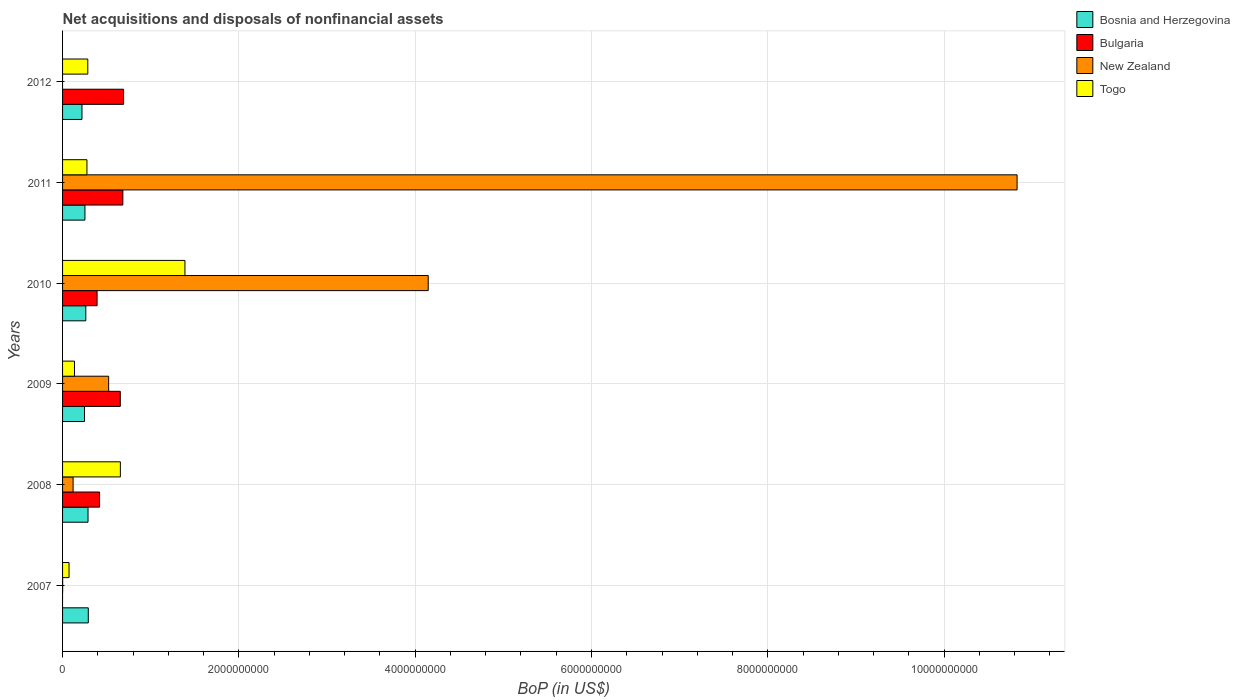Are the number of bars per tick equal to the number of legend labels?
Provide a short and direct response. No. Are the number of bars on each tick of the Y-axis equal?
Make the answer very short. No. How many bars are there on the 5th tick from the top?
Your answer should be compact. 4. What is the label of the 5th group of bars from the top?
Your answer should be compact. 2008. In how many cases, is the number of bars for a given year not equal to the number of legend labels?
Keep it short and to the point. 2. What is the Balance of Payments in Togo in 2011?
Ensure brevity in your answer.  2.76e+08. Across all years, what is the maximum Balance of Payments in Bulgaria?
Provide a succinct answer. 6.92e+08. Across all years, what is the minimum Balance of Payments in Togo?
Keep it short and to the point. 7.34e+07. In which year was the Balance of Payments in Bosnia and Herzegovina maximum?
Make the answer very short. 2007. What is the total Balance of Payments in Bulgaria in the graph?
Offer a very short reply. 2.84e+09. What is the difference between the Balance of Payments in New Zealand in 2008 and that in 2011?
Your response must be concise. -1.07e+1. What is the difference between the Balance of Payments in Bosnia and Herzegovina in 2008 and the Balance of Payments in Togo in 2012?
Give a very brief answer. 2.53e+06. What is the average Balance of Payments in Togo per year?
Provide a short and direct response. 4.69e+08. In the year 2009, what is the difference between the Balance of Payments in Togo and Balance of Payments in Bulgaria?
Offer a very short reply. -5.20e+08. What is the ratio of the Balance of Payments in New Zealand in 2009 to that in 2011?
Your answer should be compact. 0.05. Is the difference between the Balance of Payments in Togo in 2009 and 2010 greater than the difference between the Balance of Payments in Bulgaria in 2009 and 2010?
Offer a terse response. No. What is the difference between the highest and the second highest Balance of Payments in Bulgaria?
Your answer should be compact. 8.50e+06. What is the difference between the highest and the lowest Balance of Payments in Bosnia and Herzegovina?
Give a very brief answer. 7.16e+07. In how many years, is the Balance of Payments in New Zealand greater than the average Balance of Payments in New Zealand taken over all years?
Your answer should be very brief. 2. Is it the case that in every year, the sum of the Balance of Payments in Bosnia and Herzegovina and Balance of Payments in Togo is greater than the sum of Balance of Payments in New Zealand and Balance of Payments in Bulgaria?
Keep it short and to the point. No. How many years are there in the graph?
Your answer should be very brief. 6. Are the values on the major ticks of X-axis written in scientific E-notation?
Provide a succinct answer. No. Does the graph contain any zero values?
Ensure brevity in your answer.  Yes. Does the graph contain grids?
Offer a very short reply. Yes. How many legend labels are there?
Provide a succinct answer. 4. What is the title of the graph?
Provide a succinct answer. Net acquisitions and disposals of nonfinancial assets. What is the label or title of the X-axis?
Ensure brevity in your answer.  BoP (in US$). What is the BoP (in US$) in Bosnia and Herzegovina in 2007?
Your response must be concise. 2.92e+08. What is the BoP (in US$) of Bulgaria in 2007?
Give a very brief answer. 0. What is the BoP (in US$) in New Zealand in 2007?
Offer a terse response. 7.64e+05. What is the BoP (in US$) in Togo in 2007?
Your answer should be very brief. 7.34e+07. What is the BoP (in US$) of Bosnia and Herzegovina in 2008?
Give a very brief answer. 2.89e+08. What is the BoP (in US$) of Bulgaria in 2008?
Provide a short and direct response. 4.20e+08. What is the BoP (in US$) of New Zealand in 2008?
Make the answer very short. 1.19e+08. What is the BoP (in US$) of Togo in 2008?
Provide a short and direct response. 6.56e+08. What is the BoP (in US$) of Bosnia and Herzegovina in 2009?
Ensure brevity in your answer.  2.49e+08. What is the BoP (in US$) in Bulgaria in 2009?
Offer a very short reply. 6.55e+08. What is the BoP (in US$) of New Zealand in 2009?
Offer a very short reply. 5.23e+08. What is the BoP (in US$) in Togo in 2009?
Ensure brevity in your answer.  1.35e+08. What is the BoP (in US$) of Bosnia and Herzegovina in 2010?
Your answer should be compact. 2.64e+08. What is the BoP (in US$) of Bulgaria in 2010?
Offer a very short reply. 3.91e+08. What is the BoP (in US$) of New Zealand in 2010?
Ensure brevity in your answer.  4.15e+09. What is the BoP (in US$) in Togo in 2010?
Make the answer very short. 1.39e+09. What is the BoP (in US$) of Bosnia and Herzegovina in 2011?
Your response must be concise. 2.54e+08. What is the BoP (in US$) in Bulgaria in 2011?
Your response must be concise. 6.84e+08. What is the BoP (in US$) in New Zealand in 2011?
Offer a very short reply. 1.08e+1. What is the BoP (in US$) of Togo in 2011?
Offer a terse response. 2.76e+08. What is the BoP (in US$) in Bosnia and Herzegovina in 2012?
Your answer should be very brief. 2.20e+08. What is the BoP (in US$) in Bulgaria in 2012?
Provide a succinct answer. 6.92e+08. What is the BoP (in US$) in Togo in 2012?
Provide a short and direct response. 2.86e+08. Across all years, what is the maximum BoP (in US$) in Bosnia and Herzegovina?
Make the answer very short. 2.92e+08. Across all years, what is the maximum BoP (in US$) in Bulgaria?
Keep it short and to the point. 6.92e+08. Across all years, what is the maximum BoP (in US$) in New Zealand?
Your response must be concise. 1.08e+1. Across all years, what is the maximum BoP (in US$) in Togo?
Provide a short and direct response. 1.39e+09. Across all years, what is the minimum BoP (in US$) of Bosnia and Herzegovina?
Provide a short and direct response. 2.20e+08. Across all years, what is the minimum BoP (in US$) of New Zealand?
Ensure brevity in your answer.  0. Across all years, what is the minimum BoP (in US$) of Togo?
Provide a short and direct response. 7.34e+07. What is the total BoP (in US$) in Bosnia and Herzegovina in the graph?
Provide a succinct answer. 1.57e+09. What is the total BoP (in US$) in Bulgaria in the graph?
Offer a terse response. 2.84e+09. What is the total BoP (in US$) of New Zealand in the graph?
Your answer should be very brief. 1.56e+1. What is the total BoP (in US$) of Togo in the graph?
Your response must be concise. 2.82e+09. What is the difference between the BoP (in US$) in Bosnia and Herzegovina in 2007 and that in 2008?
Keep it short and to the point. 3.07e+06. What is the difference between the BoP (in US$) of New Zealand in 2007 and that in 2008?
Provide a succinct answer. -1.19e+08. What is the difference between the BoP (in US$) of Togo in 2007 and that in 2008?
Provide a succinct answer. -5.82e+08. What is the difference between the BoP (in US$) in Bosnia and Herzegovina in 2007 and that in 2009?
Provide a succinct answer. 4.26e+07. What is the difference between the BoP (in US$) in New Zealand in 2007 and that in 2009?
Your response must be concise. -5.22e+08. What is the difference between the BoP (in US$) of Togo in 2007 and that in 2009?
Your response must be concise. -6.17e+07. What is the difference between the BoP (in US$) of Bosnia and Herzegovina in 2007 and that in 2010?
Give a very brief answer. 2.82e+07. What is the difference between the BoP (in US$) in New Zealand in 2007 and that in 2010?
Your answer should be compact. -4.15e+09. What is the difference between the BoP (in US$) of Togo in 2007 and that in 2010?
Give a very brief answer. -1.31e+09. What is the difference between the BoP (in US$) of Bosnia and Herzegovina in 2007 and that in 2011?
Offer a very short reply. 3.82e+07. What is the difference between the BoP (in US$) of New Zealand in 2007 and that in 2011?
Offer a terse response. -1.08e+1. What is the difference between the BoP (in US$) of Togo in 2007 and that in 2011?
Your answer should be compact. -2.03e+08. What is the difference between the BoP (in US$) of Bosnia and Herzegovina in 2007 and that in 2012?
Provide a short and direct response. 7.16e+07. What is the difference between the BoP (in US$) of Togo in 2007 and that in 2012?
Your answer should be very brief. -2.13e+08. What is the difference between the BoP (in US$) of Bosnia and Herzegovina in 2008 and that in 2009?
Ensure brevity in your answer.  3.96e+07. What is the difference between the BoP (in US$) in Bulgaria in 2008 and that in 2009?
Your response must be concise. -2.35e+08. What is the difference between the BoP (in US$) in New Zealand in 2008 and that in 2009?
Offer a very short reply. -4.03e+08. What is the difference between the BoP (in US$) of Togo in 2008 and that in 2009?
Offer a terse response. 5.21e+08. What is the difference between the BoP (in US$) of Bosnia and Herzegovina in 2008 and that in 2010?
Keep it short and to the point. 2.51e+07. What is the difference between the BoP (in US$) in Bulgaria in 2008 and that in 2010?
Ensure brevity in your answer.  2.82e+07. What is the difference between the BoP (in US$) in New Zealand in 2008 and that in 2010?
Give a very brief answer. -4.03e+09. What is the difference between the BoP (in US$) of Togo in 2008 and that in 2010?
Your answer should be compact. -7.32e+08. What is the difference between the BoP (in US$) in Bosnia and Herzegovina in 2008 and that in 2011?
Provide a succinct answer. 3.51e+07. What is the difference between the BoP (in US$) in Bulgaria in 2008 and that in 2011?
Your response must be concise. -2.64e+08. What is the difference between the BoP (in US$) in New Zealand in 2008 and that in 2011?
Keep it short and to the point. -1.07e+1. What is the difference between the BoP (in US$) in Togo in 2008 and that in 2011?
Your answer should be very brief. 3.79e+08. What is the difference between the BoP (in US$) of Bosnia and Herzegovina in 2008 and that in 2012?
Offer a terse response. 6.85e+07. What is the difference between the BoP (in US$) of Bulgaria in 2008 and that in 2012?
Give a very brief answer. -2.73e+08. What is the difference between the BoP (in US$) of Togo in 2008 and that in 2012?
Offer a terse response. 3.70e+08. What is the difference between the BoP (in US$) of Bosnia and Herzegovina in 2009 and that in 2010?
Offer a terse response. -1.44e+07. What is the difference between the BoP (in US$) in Bulgaria in 2009 and that in 2010?
Your answer should be very brief. 2.63e+08. What is the difference between the BoP (in US$) of New Zealand in 2009 and that in 2010?
Your answer should be very brief. -3.62e+09. What is the difference between the BoP (in US$) of Togo in 2009 and that in 2010?
Offer a terse response. -1.25e+09. What is the difference between the BoP (in US$) in Bosnia and Herzegovina in 2009 and that in 2011?
Offer a very short reply. -4.48e+06. What is the difference between the BoP (in US$) in Bulgaria in 2009 and that in 2011?
Ensure brevity in your answer.  -2.90e+07. What is the difference between the BoP (in US$) in New Zealand in 2009 and that in 2011?
Ensure brevity in your answer.  -1.03e+1. What is the difference between the BoP (in US$) in Togo in 2009 and that in 2011?
Offer a very short reply. -1.41e+08. What is the difference between the BoP (in US$) of Bosnia and Herzegovina in 2009 and that in 2012?
Give a very brief answer. 2.90e+07. What is the difference between the BoP (in US$) of Bulgaria in 2009 and that in 2012?
Offer a very short reply. -3.75e+07. What is the difference between the BoP (in US$) in Togo in 2009 and that in 2012?
Keep it short and to the point. -1.51e+08. What is the difference between the BoP (in US$) in Bosnia and Herzegovina in 2010 and that in 2011?
Offer a terse response. 9.94e+06. What is the difference between the BoP (in US$) in Bulgaria in 2010 and that in 2011?
Make the answer very short. -2.92e+08. What is the difference between the BoP (in US$) in New Zealand in 2010 and that in 2011?
Your answer should be compact. -6.68e+09. What is the difference between the BoP (in US$) of Togo in 2010 and that in 2011?
Ensure brevity in your answer.  1.11e+09. What is the difference between the BoP (in US$) in Bosnia and Herzegovina in 2010 and that in 2012?
Offer a terse response. 4.34e+07. What is the difference between the BoP (in US$) in Bulgaria in 2010 and that in 2012?
Offer a very short reply. -3.01e+08. What is the difference between the BoP (in US$) of Togo in 2010 and that in 2012?
Your response must be concise. 1.10e+09. What is the difference between the BoP (in US$) of Bosnia and Herzegovina in 2011 and that in 2012?
Keep it short and to the point. 3.34e+07. What is the difference between the BoP (in US$) in Bulgaria in 2011 and that in 2012?
Offer a terse response. -8.50e+06. What is the difference between the BoP (in US$) of Togo in 2011 and that in 2012?
Your answer should be compact. -9.80e+06. What is the difference between the BoP (in US$) in Bosnia and Herzegovina in 2007 and the BoP (in US$) in Bulgaria in 2008?
Make the answer very short. -1.28e+08. What is the difference between the BoP (in US$) of Bosnia and Herzegovina in 2007 and the BoP (in US$) of New Zealand in 2008?
Your answer should be very brief. 1.72e+08. What is the difference between the BoP (in US$) in Bosnia and Herzegovina in 2007 and the BoP (in US$) in Togo in 2008?
Keep it short and to the point. -3.64e+08. What is the difference between the BoP (in US$) of New Zealand in 2007 and the BoP (in US$) of Togo in 2008?
Give a very brief answer. -6.55e+08. What is the difference between the BoP (in US$) of Bosnia and Herzegovina in 2007 and the BoP (in US$) of Bulgaria in 2009?
Offer a very short reply. -3.63e+08. What is the difference between the BoP (in US$) in Bosnia and Herzegovina in 2007 and the BoP (in US$) in New Zealand in 2009?
Offer a very short reply. -2.31e+08. What is the difference between the BoP (in US$) in Bosnia and Herzegovina in 2007 and the BoP (in US$) in Togo in 2009?
Make the answer very short. 1.57e+08. What is the difference between the BoP (in US$) of New Zealand in 2007 and the BoP (in US$) of Togo in 2009?
Provide a short and direct response. -1.34e+08. What is the difference between the BoP (in US$) of Bosnia and Herzegovina in 2007 and the BoP (in US$) of Bulgaria in 2010?
Ensure brevity in your answer.  -9.96e+07. What is the difference between the BoP (in US$) in Bosnia and Herzegovina in 2007 and the BoP (in US$) in New Zealand in 2010?
Your answer should be very brief. -3.86e+09. What is the difference between the BoP (in US$) in Bosnia and Herzegovina in 2007 and the BoP (in US$) in Togo in 2010?
Provide a short and direct response. -1.10e+09. What is the difference between the BoP (in US$) of New Zealand in 2007 and the BoP (in US$) of Togo in 2010?
Your response must be concise. -1.39e+09. What is the difference between the BoP (in US$) of Bosnia and Herzegovina in 2007 and the BoP (in US$) of Bulgaria in 2011?
Your answer should be compact. -3.92e+08. What is the difference between the BoP (in US$) of Bosnia and Herzegovina in 2007 and the BoP (in US$) of New Zealand in 2011?
Give a very brief answer. -1.05e+1. What is the difference between the BoP (in US$) in Bosnia and Herzegovina in 2007 and the BoP (in US$) in Togo in 2011?
Your response must be concise. 1.54e+07. What is the difference between the BoP (in US$) in New Zealand in 2007 and the BoP (in US$) in Togo in 2011?
Your answer should be compact. -2.76e+08. What is the difference between the BoP (in US$) in Bosnia and Herzegovina in 2007 and the BoP (in US$) in Bulgaria in 2012?
Make the answer very short. -4.00e+08. What is the difference between the BoP (in US$) in Bosnia and Herzegovina in 2007 and the BoP (in US$) in Togo in 2012?
Your response must be concise. 5.60e+06. What is the difference between the BoP (in US$) of New Zealand in 2007 and the BoP (in US$) of Togo in 2012?
Make the answer very short. -2.86e+08. What is the difference between the BoP (in US$) of Bosnia and Herzegovina in 2008 and the BoP (in US$) of Bulgaria in 2009?
Offer a very short reply. -3.66e+08. What is the difference between the BoP (in US$) in Bosnia and Herzegovina in 2008 and the BoP (in US$) in New Zealand in 2009?
Your answer should be very brief. -2.34e+08. What is the difference between the BoP (in US$) of Bosnia and Herzegovina in 2008 and the BoP (in US$) of Togo in 2009?
Make the answer very short. 1.54e+08. What is the difference between the BoP (in US$) of Bulgaria in 2008 and the BoP (in US$) of New Zealand in 2009?
Your response must be concise. -1.03e+08. What is the difference between the BoP (in US$) of Bulgaria in 2008 and the BoP (in US$) of Togo in 2009?
Your answer should be compact. 2.84e+08. What is the difference between the BoP (in US$) of New Zealand in 2008 and the BoP (in US$) of Togo in 2009?
Offer a very short reply. -1.57e+07. What is the difference between the BoP (in US$) in Bosnia and Herzegovina in 2008 and the BoP (in US$) in Bulgaria in 2010?
Offer a very short reply. -1.03e+08. What is the difference between the BoP (in US$) of Bosnia and Herzegovina in 2008 and the BoP (in US$) of New Zealand in 2010?
Offer a terse response. -3.86e+09. What is the difference between the BoP (in US$) of Bosnia and Herzegovina in 2008 and the BoP (in US$) of Togo in 2010?
Give a very brief answer. -1.10e+09. What is the difference between the BoP (in US$) of Bulgaria in 2008 and the BoP (in US$) of New Zealand in 2010?
Your response must be concise. -3.73e+09. What is the difference between the BoP (in US$) of Bulgaria in 2008 and the BoP (in US$) of Togo in 2010?
Offer a very short reply. -9.68e+08. What is the difference between the BoP (in US$) of New Zealand in 2008 and the BoP (in US$) of Togo in 2010?
Offer a very short reply. -1.27e+09. What is the difference between the BoP (in US$) in Bosnia and Herzegovina in 2008 and the BoP (in US$) in Bulgaria in 2011?
Your answer should be compact. -3.95e+08. What is the difference between the BoP (in US$) in Bosnia and Herzegovina in 2008 and the BoP (in US$) in New Zealand in 2011?
Keep it short and to the point. -1.05e+1. What is the difference between the BoP (in US$) of Bosnia and Herzegovina in 2008 and the BoP (in US$) of Togo in 2011?
Your response must be concise. 1.23e+07. What is the difference between the BoP (in US$) of Bulgaria in 2008 and the BoP (in US$) of New Zealand in 2011?
Make the answer very short. -1.04e+1. What is the difference between the BoP (in US$) of Bulgaria in 2008 and the BoP (in US$) of Togo in 2011?
Your answer should be compact. 1.43e+08. What is the difference between the BoP (in US$) of New Zealand in 2008 and the BoP (in US$) of Togo in 2011?
Make the answer very short. -1.57e+08. What is the difference between the BoP (in US$) of Bosnia and Herzegovina in 2008 and the BoP (in US$) of Bulgaria in 2012?
Your response must be concise. -4.03e+08. What is the difference between the BoP (in US$) in Bosnia and Herzegovina in 2008 and the BoP (in US$) in Togo in 2012?
Offer a terse response. 2.53e+06. What is the difference between the BoP (in US$) of Bulgaria in 2008 and the BoP (in US$) of Togo in 2012?
Provide a short and direct response. 1.33e+08. What is the difference between the BoP (in US$) of New Zealand in 2008 and the BoP (in US$) of Togo in 2012?
Your response must be concise. -1.67e+08. What is the difference between the BoP (in US$) in Bosnia and Herzegovina in 2009 and the BoP (in US$) in Bulgaria in 2010?
Your answer should be very brief. -1.42e+08. What is the difference between the BoP (in US$) of Bosnia and Herzegovina in 2009 and the BoP (in US$) of New Zealand in 2010?
Provide a succinct answer. -3.90e+09. What is the difference between the BoP (in US$) of Bosnia and Herzegovina in 2009 and the BoP (in US$) of Togo in 2010?
Your answer should be compact. -1.14e+09. What is the difference between the BoP (in US$) in Bulgaria in 2009 and the BoP (in US$) in New Zealand in 2010?
Your answer should be very brief. -3.49e+09. What is the difference between the BoP (in US$) in Bulgaria in 2009 and the BoP (in US$) in Togo in 2010?
Your response must be concise. -7.33e+08. What is the difference between the BoP (in US$) of New Zealand in 2009 and the BoP (in US$) of Togo in 2010?
Provide a succinct answer. -8.65e+08. What is the difference between the BoP (in US$) of Bosnia and Herzegovina in 2009 and the BoP (in US$) of Bulgaria in 2011?
Your answer should be very brief. -4.35e+08. What is the difference between the BoP (in US$) of Bosnia and Herzegovina in 2009 and the BoP (in US$) of New Zealand in 2011?
Make the answer very short. -1.06e+1. What is the difference between the BoP (in US$) in Bosnia and Herzegovina in 2009 and the BoP (in US$) in Togo in 2011?
Make the answer very short. -2.72e+07. What is the difference between the BoP (in US$) in Bulgaria in 2009 and the BoP (in US$) in New Zealand in 2011?
Your response must be concise. -1.02e+1. What is the difference between the BoP (in US$) in Bulgaria in 2009 and the BoP (in US$) in Togo in 2011?
Make the answer very short. 3.78e+08. What is the difference between the BoP (in US$) in New Zealand in 2009 and the BoP (in US$) in Togo in 2011?
Make the answer very short. 2.46e+08. What is the difference between the BoP (in US$) of Bosnia and Herzegovina in 2009 and the BoP (in US$) of Bulgaria in 2012?
Your answer should be very brief. -4.43e+08. What is the difference between the BoP (in US$) in Bosnia and Herzegovina in 2009 and the BoP (in US$) in Togo in 2012?
Ensure brevity in your answer.  -3.70e+07. What is the difference between the BoP (in US$) of Bulgaria in 2009 and the BoP (in US$) of Togo in 2012?
Give a very brief answer. 3.68e+08. What is the difference between the BoP (in US$) of New Zealand in 2009 and the BoP (in US$) of Togo in 2012?
Offer a terse response. 2.37e+08. What is the difference between the BoP (in US$) of Bosnia and Herzegovina in 2010 and the BoP (in US$) of Bulgaria in 2011?
Offer a very short reply. -4.20e+08. What is the difference between the BoP (in US$) of Bosnia and Herzegovina in 2010 and the BoP (in US$) of New Zealand in 2011?
Give a very brief answer. -1.06e+1. What is the difference between the BoP (in US$) of Bosnia and Herzegovina in 2010 and the BoP (in US$) of Togo in 2011?
Offer a terse response. -1.28e+07. What is the difference between the BoP (in US$) of Bulgaria in 2010 and the BoP (in US$) of New Zealand in 2011?
Your answer should be very brief. -1.04e+1. What is the difference between the BoP (in US$) in Bulgaria in 2010 and the BoP (in US$) in Togo in 2011?
Offer a terse response. 1.15e+08. What is the difference between the BoP (in US$) of New Zealand in 2010 and the BoP (in US$) of Togo in 2011?
Your answer should be very brief. 3.87e+09. What is the difference between the BoP (in US$) in Bosnia and Herzegovina in 2010 and the BoP (in US$) in Bulgaria in 2012?
Ensure brevity in your answer.  -4.29e+08. What is the difference between the BoP (in US$) in Bosnia and Herzegovina in 2010 and the BoP (in US$) in Togo in 2012?
Provide a short and direct response. -2.26e+07. What is the difference between the BoP (in US$) of Bulgaria in 2010 and the BoP (in US$) of Togo in 2012?
Give a very brief answer. 1.05e+08. What is the difference between the BoP (in US$) in New Zealand in 2010 and the BoP (in US$) in Togo in 2012?
Offer a terse response. 3.86e+09. What is the difference between the BoP (in US$) of Bosnia and Herzegovina in 2011 and the BoP (in US$) of Bulgaria in 2012?
Provide a succinct answer. -4.39e+08. What is the difference between the BoP (in US$) of Bosnia and Herzegovina in 2011 and the BoP (in US$) of Togo in 2012?
Offer a terse response. -3.25e+07. What is the difference between the BoP (in US$) in Bulgaria in 2011 and the BoP (in US$) in Togo in 2012?
Ensure brevity in your answer.  3.98e+08. What is the difference between the BoP (in US$) of New Zealand in 2011 and the BoP (in US$) of Togo in 2012?
Provide a succinct answer. 1.05e+1. What is the average BoP (in US$) of Bosnia and Herzegovina per year?
Offer a very short reply. 2.61e+08. What is the average BoP (in US$) of Bulgaria per year?
Provide a short and direct response. 4.74e+08. What is the average BoP (in US$) in New Zealand per year?
Your answer should be compact. 2.60e+09. What is the average BoP (in US$) of Togo per year?
Offer a terse response. 4.69e+08. In the year 2007, what is the difference between the BoP (in US$) in Bosnia and Herzegovina and BoP (in US$) in New Zealand?
Keep it short and to the point. 2.91e+08. In the year 2007, what is the difference between the BoP (in US$) of Bosnia and Herzegovina and BoP (in US$) of Togo?
Provide a succinct answer. 2.18e+08. In the year 2007, what is the difference between the BoP (in US$) of New Zealand and BoP (in US$) of Togo?
Provide a short and direct response. -7.27e+07. In the year 2008, what is the difference between the BoP (in US$) in Bosnia and Herzegovina and BoP (in US$) in Bulgaria?
Offer a very short reply. -1.31e+08. In the year 2008, what is the difference between the BoP (in US$) of Bosnia and Herzegovina and BoP (in US$) of New Zealand?
Your answer should be very brief. 1.69e+08. In the year 2008, what is the difference between the BoP (in US$) in Bosnia and Herzegovina and BoP (in US$) in Togo?
Provide a succinct answer. -3.67e+08. In the year 2008, what is the difference between the BoP (in US$) in Bulgaria and BoP (in US$) in New Zealand?
Offer a very short reply. 3.00e+08. In the year 2008, what is the difference between the BoP (in US$) in Bulgaria and BoP (in US$) in Togo?
Your response must be concise. -2.36e+08. In the year 2008, what is the difference between the BoP (in US$) in New Zealand and BoP (in US$) in Togo?
Keep it short and to the point. -5.36e+08. In the year 2009, what is the difference between the BoP (in US$) in Bosnia and Herzegovina and BoP (in US$) in Bulgaria?
Offer a terse response. -4.06e+08. In the year 2009, what is the difference between the BoP (in US$) of Bosnia and Herzegovina and BoP (in US$) of New Zealand?
Offer a very short reply. -2.74e+08. In the year 2009, what is the difference between the BoP (in US$) of Bosnia and Herzegovina and BoP (in US$) of Togo?
Keep it short and to the point. 1.14e+08. In the year 2009, what is the difference between the BoP (in US$) in Bulgaria and BoP (in US$) in New Zealand?
Give a very brief answer. 1.32e+08. In the year 2009, what is the difference between the BoP (in US$) in Bulgaria and BoP (in US$) in Togo?
Keep it short and to the point. 5.20e+08. In the year 2009, what is the difference between the BoP (in US$) in New Zealand and BoP (in US$) in Togo?
Your response must be concise. 3.88e+08. In the year 2010, what is the difference between the BoP (in US$) of Bosnia and Herzegovina and BoP (in US$) of Bulgaria?
Provide a short and direct response. -1.28e+08. In the year 2010, what is the difference between the BoP (in US$) of Bosnia and Herzegovina and BoP (in US$) of New Zealand?
Give a very brief answer. -3.88e+09. In the year 2010, what is the difference between the BoP (in US$) in Bosnia and Herzegovina and BoP (in US$) in Togo?
Your answer should be compact. -1.12e+09. In the year 2010, what is the difference between the BoP (in US$) of Bulgaria and BoP (in US$) of New Zealand?
Offer a very short reply. -3.76e+09. In the year 2010, what is the difference between the BoP (in US$) of Bulgaria and BoP (in US$) of Togo?
Offer a very short reply. -9.97e+08. In the year 2010, what is the difference between the BoP (in US$) in New Zealand and BoP (in US$) in Togo?
Offer a very short reply. 2.76e+09. In the year 2011, what is the difference between the BoP (in US$) in Bosnia and Herzegovina and BoP (in US$) in Bulgaria?
Make the answer very short. -4.30e+08. In the year 2011, what is the difference between the BoP (in US$) in Bosnia and Herzegovina and BoP (in US$) in New Zealand?
Provide a short and direct response. -1.06e+1. In the year 2011, what is the difference between the BoP (in US$) in Bosnia and Herzegovina and BoP (in US$) in Togo?
Give a very brief answer. -2.28e+07. In the year 2011, what is the difference between the BoP (in US$) in Bulgaria and BoP (in US$) in New Zealand?
Your answer should be very brief. -1.01e+1. In the year 2011, what is the difference between the BoP (in US$) of Bulgaria and BoP (in US$) of Togo?
Ensure brevity in your answer.  4.07e+08. In the year 2011, what is the difference between the BoP (in US$) of New Zealand and BoP (in US$) of Togo?
Provide a short and direct response. 1.06e+1. In the year 2012, what is the difference between the BoP (in US$) in Bosnia and Herzegovina and BoP (in US$) in Bulgaria?
Your answer should be very brief. -4.72e+08. In the year 2012, what is the difference between the BoP (in US$) of Bosnia and Herzegovina and BoP (in US$) of Togo?
Offer a terse response. -6.60e+07. In the year 2012, what is the difference between the BoP (in US$) in Bulgaria and BoP (in US$) in Togo?
Ensure brevity in your answer.  4.06e+08. What is the ratio of the BoP (in US$) in Bosnia and Herzegovina in 2007 to that in 2008?
Offer a terse response. 1.01. What is the ratio of the BoP (in US$) of New Zealand in 2007 to that in 2008?
Give a very brief answer. 0.01. What is the ratio of the BoP (in US$) in Togo in 2007 to that in 2008?
Provide a succinct answer. 0.11. What is the ratio of the BoP (in US$) in Bosnia and Herzegovina in 2007 to that in 2009?
Your response must be concise. 1.17. What is the ratio of the BoP (in US$) of New Zealand in 2007 to that in 2009?
Your answer should be very brief. 0. What is the ratio of the BoP (in US$) of Togo in 2007 to that in 2009?
Provide a short and direct response. 0.54. What is the ratio of the BoP (in US$) in Bosnia and Herzegovina in 2007 to that in 2010?
Keep it short and to the point. 1.11. What is the ratio of the BoP (in US$) in Togo in 2007 to that in 2010?
Provide a succinct answer. 0.05. What is the ratio of the BoP (in US$) in Bosnia and Herzegovina in 2007 to that in 2011?
Provide a succinct answer. 1.15. What is the ratio of the BoP (in US$) in New Zealand in 2007 to that in 2011?
Ensure brevity in your answer.  0. What is the ratio of the BoP (in US$) of Togo in 2007 to that in 2011?
Ensure brevity in your answer.  0.27. What is the ratio of the BoP (in US$) of Bosnia and Herzegovina in 2007 to that in 2012?
Provide a succinct answer. 1.32. What is the ratio of the BoP (in US$) in Togo in 2007 to that in 2012?
Provide a succinct answer. 0.26. What is the ratio of the BoP (in US$) in Bosnia and Herzegovina in 2008 to that in 2009?
Offer a very short reply. 1.16. What is the ratio of the BoP (in US$) in Bulgaria in 2008 to that in 2009?
Offer a terse response. 0.64. What is the ratio of the BoP (in US$) of New Zealand in 2008 to that in 2009?
Provide a short and direct response. 0.23. What is the ratio of the BoP (in US$) of Togo in 2008 to that in 2009?
Provide a short and direct response. 4.85. What is the ratio of the BoP (in US$) in Bosnia and Herzegovina in 2008 to that in 2010?
Offer a very short reply. 1.1. What is the ratio of the BoP (in US$) in Bulgaria in 2008 to that in 2010?
Keep it short and to the point. 1.07. What is the ratio of the BoP (in US$) in New Zealand in 2008 to that in 2010?
Provide a succinct answer. 0.03. What is the ratio of the BoP (in US$) of Togo in 2008 to that in 2010?
Your answer should be compact. 0.47. What is the ratio of the BoP (in US$) in Bosnia and Herzegovina in 2008 to that in 2011?
Give a very brief answer. 1.14. What is the ratio of the BoP (in US$) of Bulgaria in 2008 to that in 2011?
Provide a succinct answer. 0.61. What is the ratio of the BoP (in US$) in New Zealand in 2008 to that in 2011?
Provide a short and direct response. 0.01. What is the ratio of the BoP (in US$) of Togo in 2008 to that in 2011?
Provide a succinct answer. 2.37. What is the ratio of the BoP (in US$) of Bosnia and Herzegovina in 2008 to that in 2012?
Make the answer very short. 1.31. What is the ratio of the BoP (in US$) of Bulgaria in 2008 to that in 2012?
Your response must be concise. 0.61. What is the ratio of the BoP (in US$) in Togo in 2008 to that in 2012?
Provide a short and direct response. 2.29. What is the ratio of the BoP (in US$) of Bosnia and Herzegovina in 2009 to that in 2010?
Offer a very short reply. 0.95. What is the ratio of the BoP (in US$) in Bulgaria in 2009 to that in 2010?
Offer a terse response. 1.67. What is the ratio of the BoP (in US$) in New Zealand in 2009 to that in 2010?
Your answer should be very brief. 0.13. What is the ratio of the BoP (in US$) in Togo in 2009 to that in 2010?
Keep it short and to the point. 0.1. What is the ratio of the BoP (in US$) of Bosnia and Herzegovina in 2009 to that in 2011?
Provide a succinct answer. 0.98. What is the ratio of the BoP (in US$) of Bulgaria in 2009 to that in 2011?
Provide a succinct answer. 0.96. What is the ratio of the BoP (in US$) in New Zealand in 2009 to that in 2011?
Your response must be concise. 0.05. What is the ratio of the BoP (in US$) of Togo in 2009 to that in 2011?
Your answer should be very brief. 0.49. What is the ratio of the BoP (in US$) in Bosnia and Herzegovina in 2009 to that in 2012?
Keep it short and to the point. 1.13. What is the ratio of the BoP (in US$) of Bulgaria in 2009 to that in 2012?
Your answer should be very brief. 0.95. What is the ratio of the BoP (in US$) of Togo in 2009 to that in 2012?
Your answer should be very brief. 0.47. What is the ratio of the BoP (in US$) of Bosnia and Herzegovina in 2010 to that in 2011?
Provide a short and direct response. 1.04. What is the ratio of the BoP (in US$) of Bulgaria in 2010 to that in 2011?
Your answer should be compact. 0.57. What is the ratio of the BoP (in US$) in New Zealand in 2010 to that in 2011?
Your answer should be compact. 0.38. What is the ratio of the BoP (in US$) in Togo in 2010 to that in 2011?
Your response must be concise. 5.02. What is the ratio of the BoP (in US$) in Bosnia and Herzegovina in 2010 to that in 2012?
Keep it short and to the point. 1.2. What is the ratio of the BoP (in US$) in Bulgaria in 2010 to that in 2012?
Provide a succinct answer. 0.57. What is the ratio of the BoP (in US$) in Togo in 2010 to that in 2012?
Provide a succinct answer. 4.85. What is the ratio of the BoP (in US$) of Bosnia and Herzegovina in 2011 to that in 2012?
Your answer should be compact. 1.15. What is the ratio of the BoP (in US$) in Togo in 2011 to that in 2012?
Your response must be concise. 0.97. What is the difference between the highest and the second highest BoP (in US$) in Bosnia and Herzegovina?
Your response must be concise. 3.07e+06. What is the difference between the highest and the second highest BoP (in US$) of Bulgaria?
Keep it short and to the point. 8.50e+06. What is the difference between the highest and the second highest BoP (in US$) in New Zealand?
Give a very brief answer. 6.68e+09. What is the difference between the highest and the second highest BoP (in US$) of Togo?
Offer a terse response. 7.32e+08. What is the difference between the highest and the lowest BoP (in US$) in Bosnia and Herzegovina?
Your answer should be compact. 7.16e+07. What is the difference between the highest and the lowest BoP (in US$) in Bulgaria?
Provide a short and direct response. 6.92e+08. What is the difference between the highest and the lowest BoP (in US$) in New Zealand?
Ensure brevity in your answer.  1.08e+1. What is the difference between the highest and the lowest BoP (in US$) in Togo?
Give a very brief answer. 1.31e+09. 